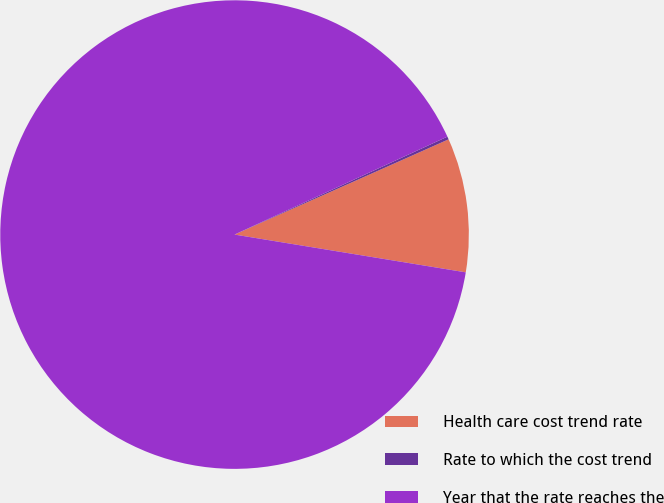<chart> <loc_0><loc_0><loc_500><loc_500><pie_chart><fcel>Health care cost trend rate<fcel>Rate to which the cost trend<fcel>Year that the rate reaches the<nl><fcel>9.24%<fcel>0.2%<fcel>90.56%<nl></chart> 